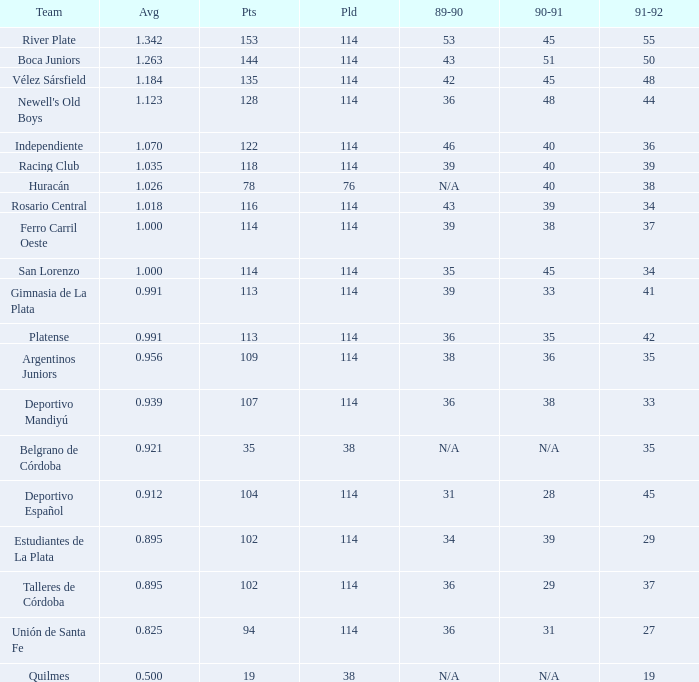How much Average has a 1989-90 of 36, and a Team of talleres de córdoba, and a Played smaller than 114? 0.0. 